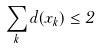Convert formula to latex. <formula><loc_0><loc_0><loc_500><loc_500>\sum _ { k } d ( x _ { k } ) \leq 2</formula> 